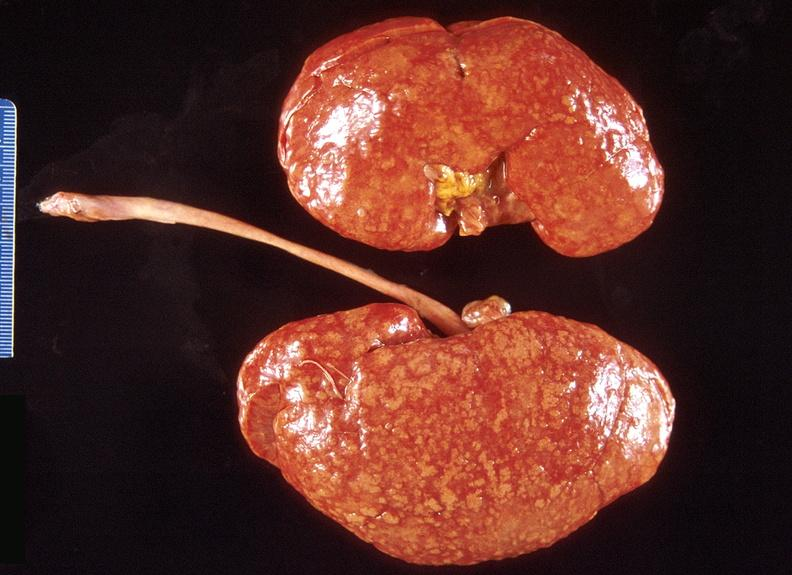what does this image show?
Answer the question using a single word or phrase. Kidney 